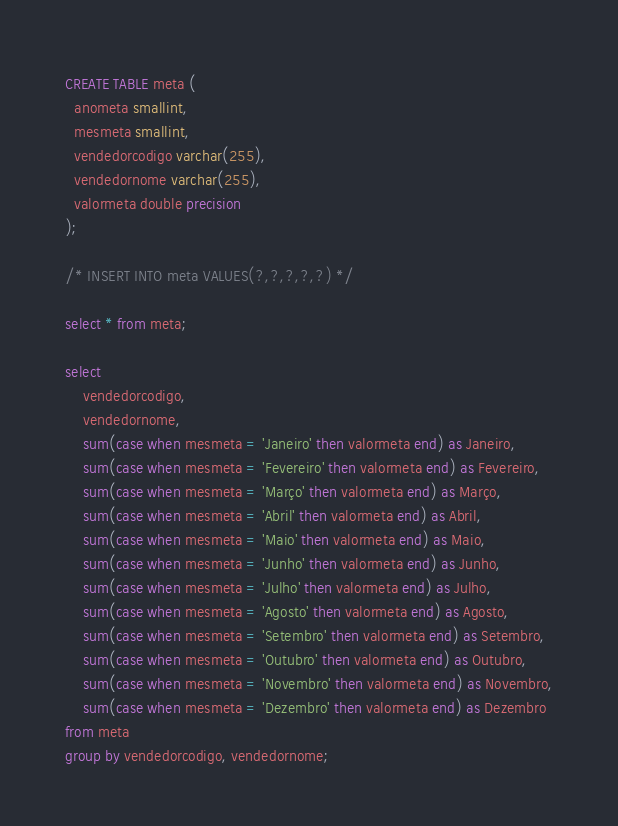<code> <loc_0><loc_0><loc_500><loc_500><_SQL_>CREATE TABLE meta (
  anometa smallint,
  mesmeta smallint,
  vendedorcodigo varchar(255),
  vendedornome varchar(255),
  valormeta double precision
);

/* INSERT INTO meta VALUES(?,?,?,?,?) */

select * from meta;

select 
    vendedorcodigo,
    vendedornome,
    sum(case when mesmeta = 'Janeiro' then valormeta end) as Janeiro,
    sum(case when mesmeta = 'Fevereiro' then valormeta end) as Fevereiro,
    sum(case when mesmeta = 'Março' then valormeta end) as Março,
    sum(case when mesmeta = 'Abril' then valormeta end) as Abril,
    sum(case when mesmeta = 'Maio' then valormeta end) as Maio,
    sum(case when mesmeta = 'Junho' then valormeta end) as Junho,
    sum(case when mesmeta = 'Julho' then valormeta end) as Julho,
    sum(case when mesmeta = 'Agosto' then valormeta end) as Agosto,
    sum(case when mesmeta = 'Setembro' then valormeta end) as Setembro,
    sum(case when mesmeta = 'Outubro' then valormeta end) as Outubro,
    sum(case when mesmeta = 'Novembro' then valormeta end) as Novembro,
    sum(case when mesmeta = 'Dezembro' then valormeta end) as Dezembro
from meta
group by vendedorcodigo, vendedornome;</code> 